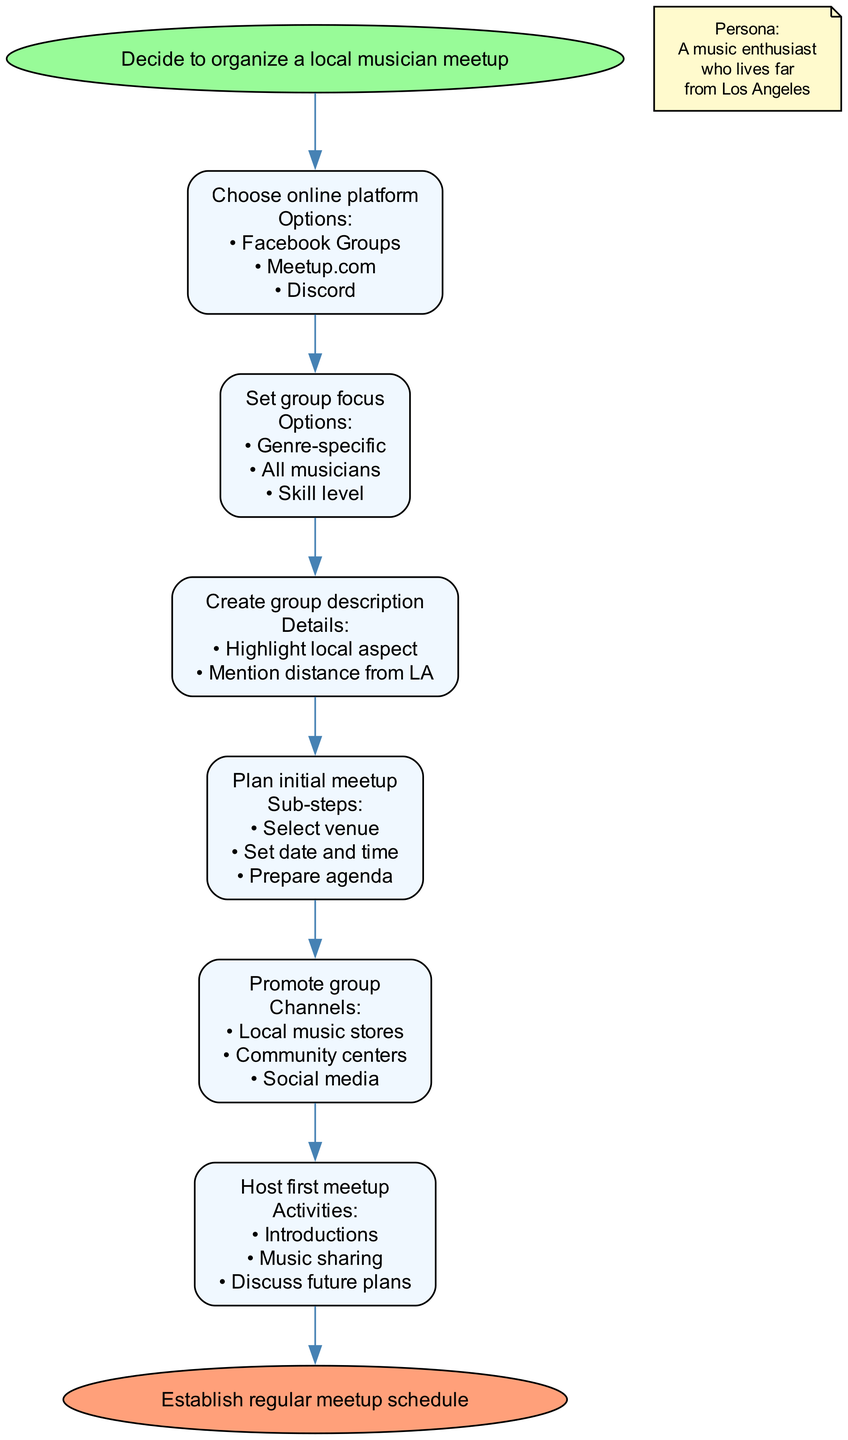What is the first step in organizing a local musician meetup? The first step is labeled as "Decide to organize a local musician meetup," which indicates the starting point of the process.
Answer: Decide to organize a local musician meetup How many main steps are there in the process? The process includes six main steps. This can be counted in the diagram where each step after the start represents a node.
Answer: 6 What online platforms are suggested in the flow chart? The chart presents three options for online platforms: Facebook Groups, Meetup.com, and Discord, which are listed under the "Choose online platform" step.
Answer: Facebook Groups, Meetup.com, Discord What is the focus option that addresses all musicians? One of the options listed under "Set group focus" is "All musicians," which indicates an inclusive approach to the meetup.
Answer: All musicians What is the last step in the process? The final step is labeled as "Establish regular meetup schedule," which marks the end of the flow of instructions.
Answer: Establish regular meetup schedule Which step involves promoting the group? The step labeled "Promote group" specifically addresses promoting the group, as indicated in the diagram where the promotion is highlighted as a separate action.
Answer: Promote group What do you need to prepare before hosting the first meetup? Prior to hosting, the subgroup mentions three main preparations: Select venue, Set date and time, and Prepare agenda, which are detailed under the "Plan initial meetup" step.
Answer: Select venue, Set date and time, Prepare agenda Which step directly follows "Set group focus"? The step that follows "Set group focus" is "Create group description," indicating a sequential flow of actions in organizing the meetup group.
Answer: Create group description What activities are planned for the first meetup? The activities planned are listed under "Host first meetup," which includes Introductions, Music sharing, and Discuss future plans, indicating the interactive nature of the meetup.
Answer: Introductions, Music sharing, Discuss future plans 